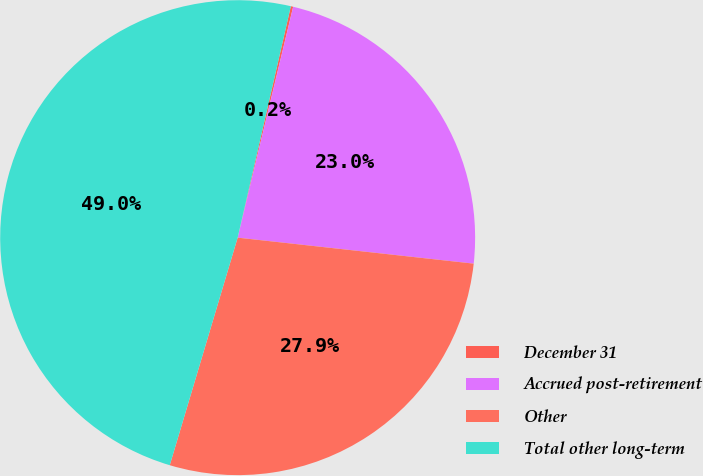Convert chart. <chart><loc_0><loc_0><loc_500><loc_500><pie_chart><fcel>December 31<fcel>Accrued post-retirement<fcel>Other<fcel>Total other long-term<nl><fcel>0.16%<fcel>22.99%<fcel>27.87%<fcel>48.98%<nl></chart> 